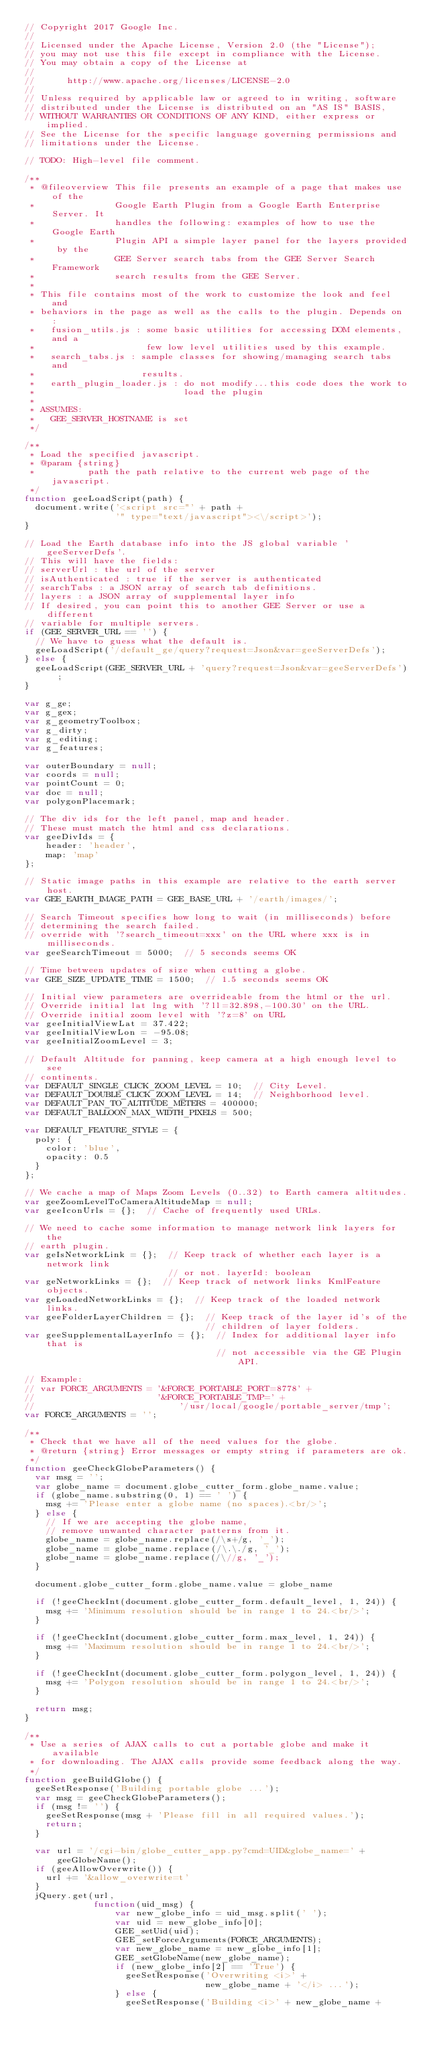<code> <loc_0><loc_0><loc_500><loc_500><_JavaScript_>// Copyright 2017 Google Inc.
//
// Licensed under the Apache License, Version 2.0 (the "License");
// you may not use this file except in compliance with the License.
// You may obtain a copy of the License at
//
//      http://www.apache.org/licenses/LICENSE-2.0
//
// Unless required by applicable law or agreed to in writing, software
// distributed under the License is distributed on an "AS IS" BASIS,
// WITHOUT WARRANTIES OR CONDITIONS OF ANY KIND, either express or implied.
// See the License for the specific language governing permissions and
// limitations under the License.

// TODO: High-level file comment.

/**
 * @fileoverview This file presents an example of a page that makes use of the
 *               Google Earth Plugin from a Google Earth Enterprise Server. It
 *               handles the following: examples of how to use the Google Earth
 *               Plugin API a simple layer panel for the layers provided by the
 *               GEE Server search tabs from the GEE Server Search Framework
 *               search results from the GEE Server.
 *
 * This file contains most of the work to customize the look and feel and
 * behaviors in the page as well as the calls to the plugin. Depends on :
 *   fusion_utils.js : some basic utilities for accessing DOM elements, and a
 *                     few low level utilities used by this example.
 *   search_tabs.js : sample classes for showing/managing search tabs and
 *                    results.
 *   earth_plugin_loader.js : do not modify...this code does the work to
 *                            load the plugin
 *
 * ASSUMES:
 *   GEE_SERVER_HOSTNAME is set
 */

/**
 * Load the specified javascript.
 * @param {string}
 *          path the path relative to the current web page of the javascript.
 */
function geeLoadScript(path) {
  document.write('<script src="' + path +
                 '" type="text/javascript"><\/script>');
}

// Load the Earth database info into the JS global variable 'geeServerDefs'.
// This will have the fields:
// serverUrl : the url of the server
// isAuthenticated : true if the server is authenticated
// searchTabs : a JSON array of search tab definitions.
// layers : a JSON array of supplemental layer info
// If desired, you can point this to another GEE Server or use a different
// variable for multiple servers.
if (GEE_SERVER_URL == '') {
  // We have to guess what the default is.
  geeLoadScript('/default_ge/query?request=Json&var=geeServerDefs');
} else {
  geeLoadScript(GEE_SERVER_URL + 'query?request=Json&var=geeServerDefs');
}

var g_ge;
var g_gex;
var g_geometryToolbox;
var g_dirty;
var g_editing;
var g_features;

var outerBoundary = null;
var coords = null;
var pointCount = 0;
var doc = null;
var polygonPlacemark;

// The div ids for the left panel, map and header.
// These must match the html and css declarations.
var geeDivIds = {
    header: 'header',
    map: 'map'
};

// Static image paths in this example are relative to the earth server host.
var GEE_EARTH_IMAGE_PATH = GEE_BASE_URL + '/earth/images/';

// Search Timeout specifies how long to wait (in milliseconds) before
// determining the search failed.
// override with '?search_timeout=xxx' on the URL where xxx is in milliseconds.
var geeSearchTimeout = 5000;  // 5 seconds seems OK

// Time between updates of size when cutting a globe.
var GEE_SIZE_UPDATE_TIME = 1500;  // 1.5 seconds seems OK

// Initial view parameters are overrideable from the html or the url.
// Override initial lat lng with '?ll=32.898,-100.30' on the URL.
// Override initial zoom level with '?z=8' on URL
var geeInitialViewLat = 37.422;
var geeInitialViewLon = -95.08;
var geeInitialZoomLevel = 3;

// Default Altitude for panning, keep camera at a high enough level to see
// continents.
var DEFAULT_SINGLE_CLICK_ZOOM_LEVEL = 10;  // City Level.
var DEFAULT_DOUBLE_CLICK_ZOOM_LEVEL = 14;  // Neighborhood level.
var DEFAULT_PAN_TO_ALTITUDE_METERS = 400000;
var DEFAULT_BALLOON_MAX_WIDTH_PIXELS = 500;

var DEFAULT_FEATURE_STYLE = {
  poly: {
    color: 'blue',
    opacity: 0.5
  }
};

// We cache a map of Maps Zoom Levels (0..32) to Earth camera altitudes.
var geeZoomLevelToCameraAltitudeMap = null;
var geeIconUrls = {};  // Cache of frequently used URLs.

// We need to cache some information to manage network link layers for the
// earth plugin.
var geIsNetworkLink = {};  // Keep track of whether each layer is a network link
                           // or not. layerId: boolean
var geNetworkLinks = {};  // Keep track of network links KmlFeature objects.
var geLoadedNetworkLinks = {};  // Keep track of the loaded network links.
var geeFolderLayerChildren = {};  // Keep track of the layer id's of the
                                  // children of layer folders.
var geeSupplementalLayerInfo = {};  // Index for additional layer info that is
                                    // not accessible via the GE Plugin API.

// Example:
// var FORCE_ARGUMENTS = '&FORCE_PORTABLE_PORT=8778' +
//                       '&FORCE_PORTABLE_TMP=' +
//                           '/usr/local/google/portable_server/tmp';
var FORCE_ARGUMENTS = '';

/**
 * Check that we have all of the need values for the globe.
 * @return {string} Error messages or empty string if parameters are ok.
 */
function geeCheckGlobeParameters() {
  var msg = '';
  var globe_name = document.globe_cutter_form.globe_name.value;
  if (globe_name.substring(0, 1) == ' ') {
    msg += 'Please enter a globe name (no spaces).<br/>';
  } else {
    // If we are accepting the globe name,
    // remove unwanted character patterns from it.
    globe_name = globe_name.replace(/\s+/g, '_');
    globe_name = globe_name.replace(/\.\./g, '_');
    globe_name = globe_name.replace(/\//g, '_');
  }

  document.globe_cutter_form.globe_name.value = globe_name

  if (!geeCheckInt(document.globe_cutter_form.default_level, 1, 24)) {
    msg += 'Minimum resolution should be in range 1 to 24.<br/>';
  }

  if (!geeCheckInt(document.globe_cutter_form.max_level, 1, 24)) {
    msg += 'Maximum resolution should be in range 1 to 24.<br/>';
  }

  if (!geeCheckInt(document.globe_cutter_form.polygon_level, 1, 24)) {
    msg += 'Polygon resolution should be in range 1 to 24.<br/>';
  }

  return msg;
}

/**
 * Use a series of AJAX calls to cut a portable globe and make it available
 * for downloading. The AJAX calls provide some feedback along the way.
 */
function geeBuildGlobe() {
  geeSetResponse('Building portable globe ...');
  var msg = geeCheckGlobeParameters();
  if (msg != '') {
    geeSetResponse(msg + 'Please fill in all required values.');
    return;
  }

  var url = '/cgi-bin/globe_cutter_app.py?cmd=UID&globe_name=' + geeGlobeName();
  if (geeAllowOverwrite()) {
    url += '&allow_overwrite=t'
  }
  jQuery.get(url,
             function(uid_msg) {
                 var new_globe_info = uid_msg.split(' ');
                 var uid = new_globe_info[0];
                 GEE_setUid(uid);
                 GEE_setForceArguments(FORCE_ARGUMENTS);
                 var new_globe_name = new_globe_info[1];
                 GEE_setGlobeName(new_globe_name);
                 if (new_globe_info[2] == 'True') {
                   geeSetResponse('Overwriting <i>' +
                                  new_globe_name + '</i> ...');
                 } else {
                   geeSetResponse('Building <i>' + new_globe_name +</code> 